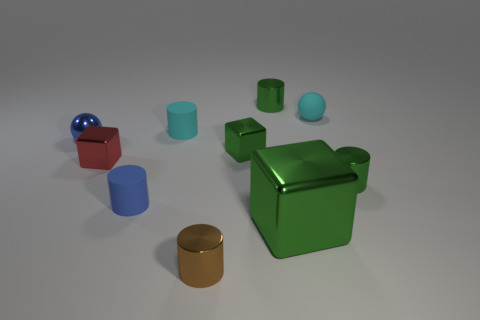What is the size of the other block that is the same color as the large shiny block?
Offer a terse response. Small. There is a cyan matte object that is to the right of the tiny cyan rubber cylinder; does it have the same shape as the tiny red thing?
Provide a succinct answer. No. Are there more matte balls that are on the left side of the brown thing than green metal cubes that are in front of the big green shiny block?
Give a very brief answer. No. What number of metallic balls are to the left of the small green cylinder that is in front of the red metal block?
Offer a very short reply. 1. What is the material of the cylinder that is the same color as the rubber sphere?
Give a very brief answer. Rubber. How many other objects are there of the same color as the shiny sphere?
Your answer should be compact. 1. The small metallic cube that is right of the matte cylinder to the right of the blue rubber object is what color?
Keep it short and to the point. Green. Is there a matte cylinder that has the same color as the big object?
Ensure brevity in your answer.  No. Is the number of small red cylinders the same as the number of matte cylinders?
Make the answer very short. No. What number of shiny objects are either blue cylinders or spheres?
Keep it short and to the point. 1. 